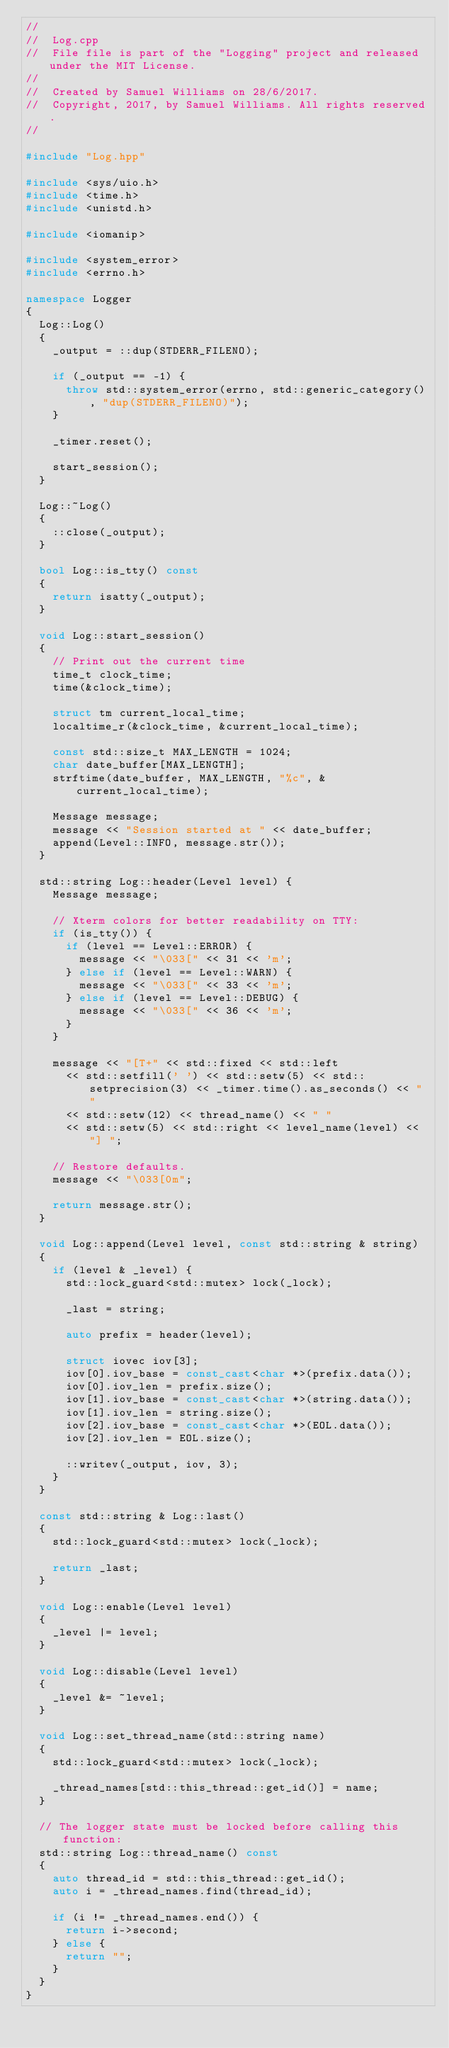Convert code to text. <code><loc_0><loc_0><loc_500><loc_500><_C++_>//
//  Log.cpp
//  File file is part of the "Logging" project and released under the MIT License.
//
//  Created by Samuel Williams on 28/6/2017.
//  Copyright, 2017, by Samuel Williams. All rights reserved.
//

#include "Log.hpp"

#include <sys/uio.h>
#include <time.h>
#include <unistd.h>

#include <iomanip>

#include <system_error>
#include <errno.h>

namespace Logger
{
	Log::Log()
	{
		_output = ::dup(STDERR_FILENO);
		
		if (_output == -1) {
			throw std::system_error(errno, std::generic_category(), "dup(STDERR_FILENO)");
		}
		
		_timer.reset();

		start_session();
	}

	Log::~Log()
	{
		::close(_output);
	}
	
	bool Log::is_tty() const
	{
		return isatty(_output);
	}
	
	void Log::start_session()
	{
		// Print out the current time
		time_t clock_time;
		time(&clock_time);

		struct tm current_local_time;
		localtime_r(&clock_time, &current_local_time);

		const std::size_t MAX_LENGTH = 1024;
		char date_buffer[MAX_LENGTH];
		strftime(date_buffer, MAX_LENGTH, "%c", &current_local_time);

		Message message;
		message << "Session started at " << date_buffer;
		append(Level::INFO, message.str());
	}

	std::string Log::header(Level level) {
		Message message;
		
		// Xterm colors for better readability on TTY:
		if (is_tty()) {
			if (level == Level::ERROR) {
				message << "\033[" << 31 << 'm';
			} else if (level == Level::WARN) {
				message << "\033[" << 33 << 'm';
			} else if (level == Level::DEBUG) {
				message << "\033[" << 36 << 'm';
			}
		}
		
		message << "[T+" << std::fixed << std::left
			<< std::setfill(' ') << std::setw(5) << std::setprecision(3) << _timer.time().as_seconds() << " "
			<< std::setw(12) << thread_name() << " "
			<< std::setw(5) << std::right << level_name(level) << "] ";
		
		// Restore defaults.
		message << "\033[0m";
		
		return message.str();
	}

	void Log::append(Level level, const std::string & string)
	{
		if (level & _level) {
			std::lock_guard<std::mutex> lock(_lock);
			
			_last = string;
			
			auto prefix = header(level);
			
			struct iovec iov[3];
			iov[0].iov_base = const_cast<char *>(prefix.data());
			iov[0].iov_len = prefix.size();
			iov[1].iov_base = const_cast<char *>(string.data());
			iov[1].iov_len = string.size();
			iov[2].iov_base = const_cast<char *>(EOL.data());
			iov[2].iov_len = EOL.size();
			
			::writev(_output, iov, 3);
		}
	}

	const std::string & Log::last()
	{
		std::lock_guard<std::mutex> lock(_lock);
		
		return _last;
	}

	void Log::enable(Level level)
	{
		_level |= level;
	}
	
	void Log::disable(Level level)
	{
		_level &= ~level;
	}

	void Log::set_thread_name(std::string name)
	{
		std::lock_guard<std::mutex> lock(_lock);
		
		_thread_names[std::this_thread::get_id()] = name;
	}

	// The logger state must be locked before calling this function:
	std::string Log::thread_name() const
	{
		auto thread_id = std::this_thread::get_id();
		auto i = _thread_names.find(thread_id);

		if (i != _thread_names.end()) {
			return i->second;
		} else {
			return "";
		}
	}
}
</code> 